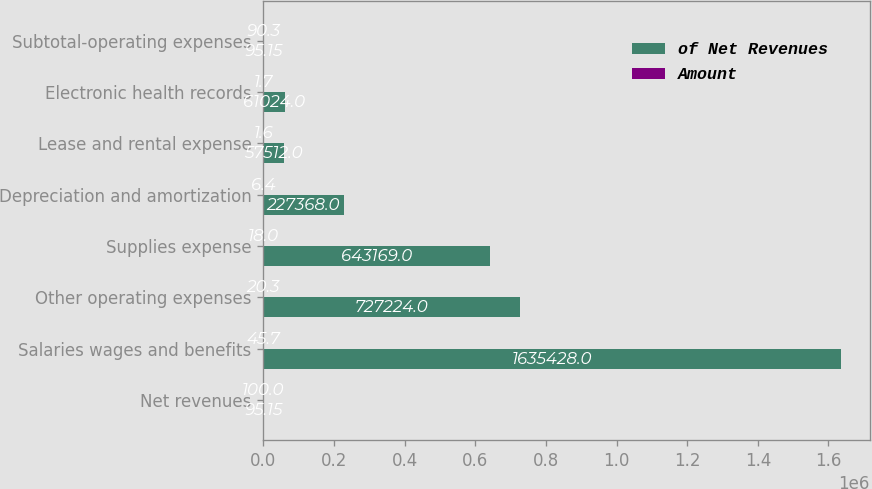Convert chart. <chart><loc_0><loc_0><loc_500><loc_500><stacked_bar_chart><ecel><fcel>Net revenues<fcel>Salaries wages and benefits<fcel>Other operating expenses<fcel>Supplies expense<fcel>Depreciation and amortization<fcel>Lease and rental expense<fcel>Electronic health records<fcel>Subtotal-operating expenses<nl><fcel>of Net Revenues<fcel>95.15<fcel>1.63543e+06<fcel>727224<fcel>643169<fcel>227368<fcel>57512<fcel>61024<fcel>95.15<nl><fcel>Amount<fcel>100<fcel>45.7<fcel>20.3<fcel>18<fcel>6.4<fcel>1.6<fcel>1.7<fcel>90.3<nl></chart> 